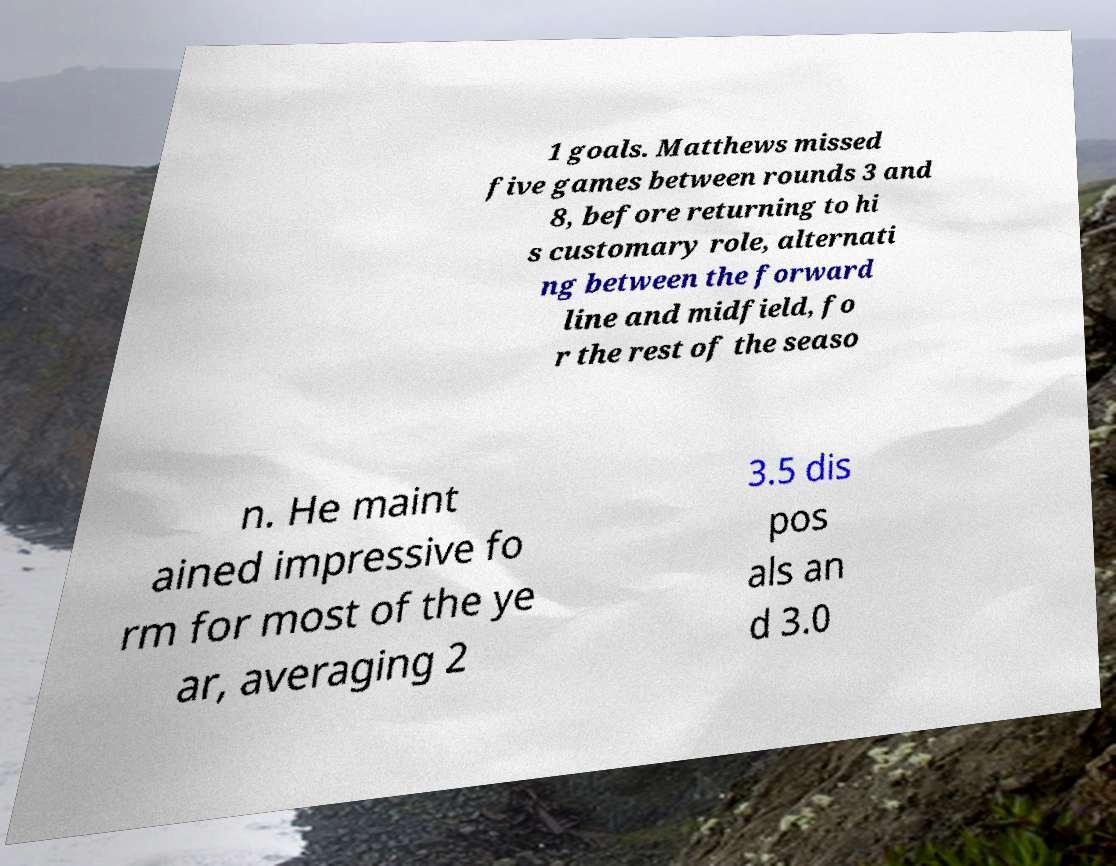Could you extract and type out the text from this image? 1 goals. Matthews missed five games between rounds 3 and 8, before returning to hi s customary role, alternati ng between the forward line and midfield, fo r the rest of the seaso n. He maint ained impressive fo rm for most of the ye ar, averaging 2 3.5 dis pos als an d 3.0 